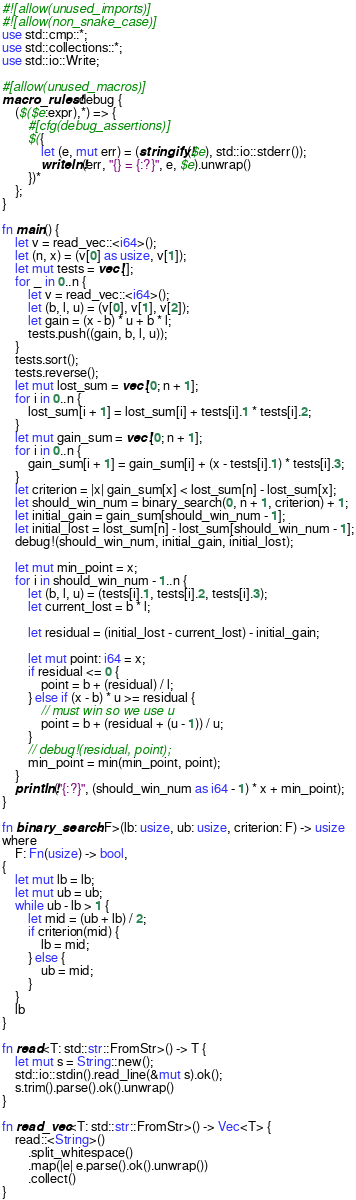<code> <loc_0><loc_0><loc_500><loc_500><_Rust_>#![allow(unused_imports)]
#![allow(non_snake_case)]
use std::cmp::*;
use std::collections::*;
use std::io::Write;

#[allow(unused_macros)]
macro_rules! debug {
    ($($e:expr),*) => {
        #[cfg(debug_assertions)]
        $({
            let (e, mut err) = (stringify!($e), std::io::stderr());
            writeln!(err, "{} = {:?}", e, $e).unwrap()
        })*
    };
}

fn main() {
    let v = read_vec::<i64>();
    let (n, x) = (v[0] as usize, v[1]);
    let mut tests = vec![];
    for _ in 0..n {
        let v = read_vec::<i64>();
        let (b, l, u) = (v[0], v[1], v[2]);
        let gain = (x - b) * u + b * l;
        tests.push((gain, b, l, u));
    }
    tests.sort();
    tests.reverse();
    let mut lost_sum = vec![0; n + 1];
    for i in 0..n {
        lost_sum[i + 1] = lost_sum[i] + tests[i].1 * tests[i].2;
    }
    let mut gain_sum = vec![0; n + 1];
    for i in 0..n {
        gain_sum[i + 1] = gain_sum[i] + (x - tests[i].1) * tests[i].3;
    }
    let criterion = |x| gain_sum[x] < lost_sum[n] - lost_sum[x];
    let should_win_num = binary_search(0, n + 1, criterion) + 1;
    let initial_gain = gain_sum[should_win_num - 1];
    let initial_lost = lost_sum[n] - lost_sum[should_win_num - 1];
    debug!(should_win_num, initial_gain, initial_lost);

    let mut min_point = x;
    for i in should_win_num - 1..n {
        let (b, l, u) = (tests[i].1, tests[i].2, tests[i].3);
        let current_lost = b * l;

        let residual = (initial_lost - current_lost) - initial_gain;

        let mut point: i64 = x;
        if residual <= 0 {
            point = b + (residual) / l;
        } else if (x - b) * u >= residual {
            // must win so we use u
            point = b + (residual + (u - 1)) / u;
        }
        // debug!(residual, point);
        min_point = min(min_point, point);
    }
    println!("{:?}", (should_win_num as i64 - 1) * x + min_point);
}

fn binary_search<F>(lb: usize, ub: usize, criterion: F) -> usize
where
    F: Fn(usize) -> bool,
{
    let mut lb = lb;
    let mut ub = ub;
    while ub - lb > 1 {
        let mid = (ub + lb) / 2;
        if criterion(mid) {
            lb = mid;
        } else {
            ub = mid;
        }
    }
    lb
}

fn read<T: std::str::FromStr>() -> T {
    let mut s = String::new();
    std::io::stdin().read_line(&mut s).ok();
    s.trim().parse().ok().unwrap()
}

fn read_vec<T: std::str::FromStr>() -> Vec<T> {
    read::<String>()
        .split_whitespace()
        .map(|e| e.parse().ok().unwrap())
        .collect()
}
</code> 